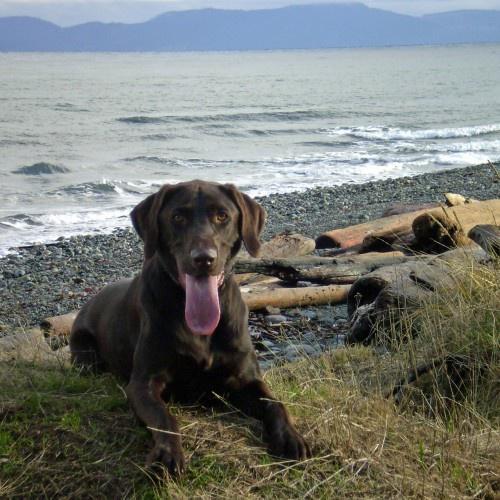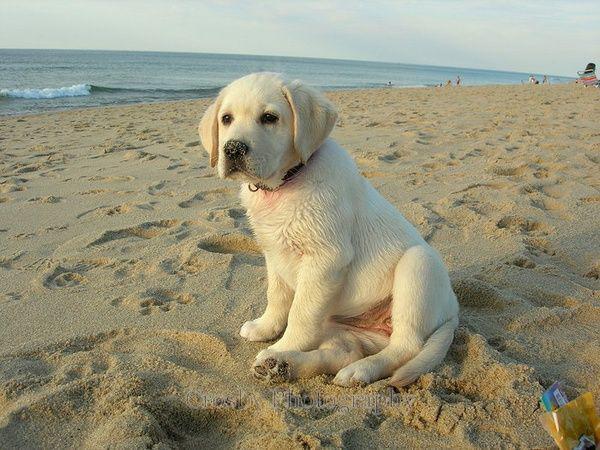The first image is the image on the left, the second image is the image on the right. For the images shown, is this caption "One of the images features a dog standing in liquid water." true? Answer yes or no. No. The first image is the image on the left, the second image is the image on the right. Assess this claim about the two images: "There are no more than two animals.". Correct or not? Answer yes or no. Yes. 